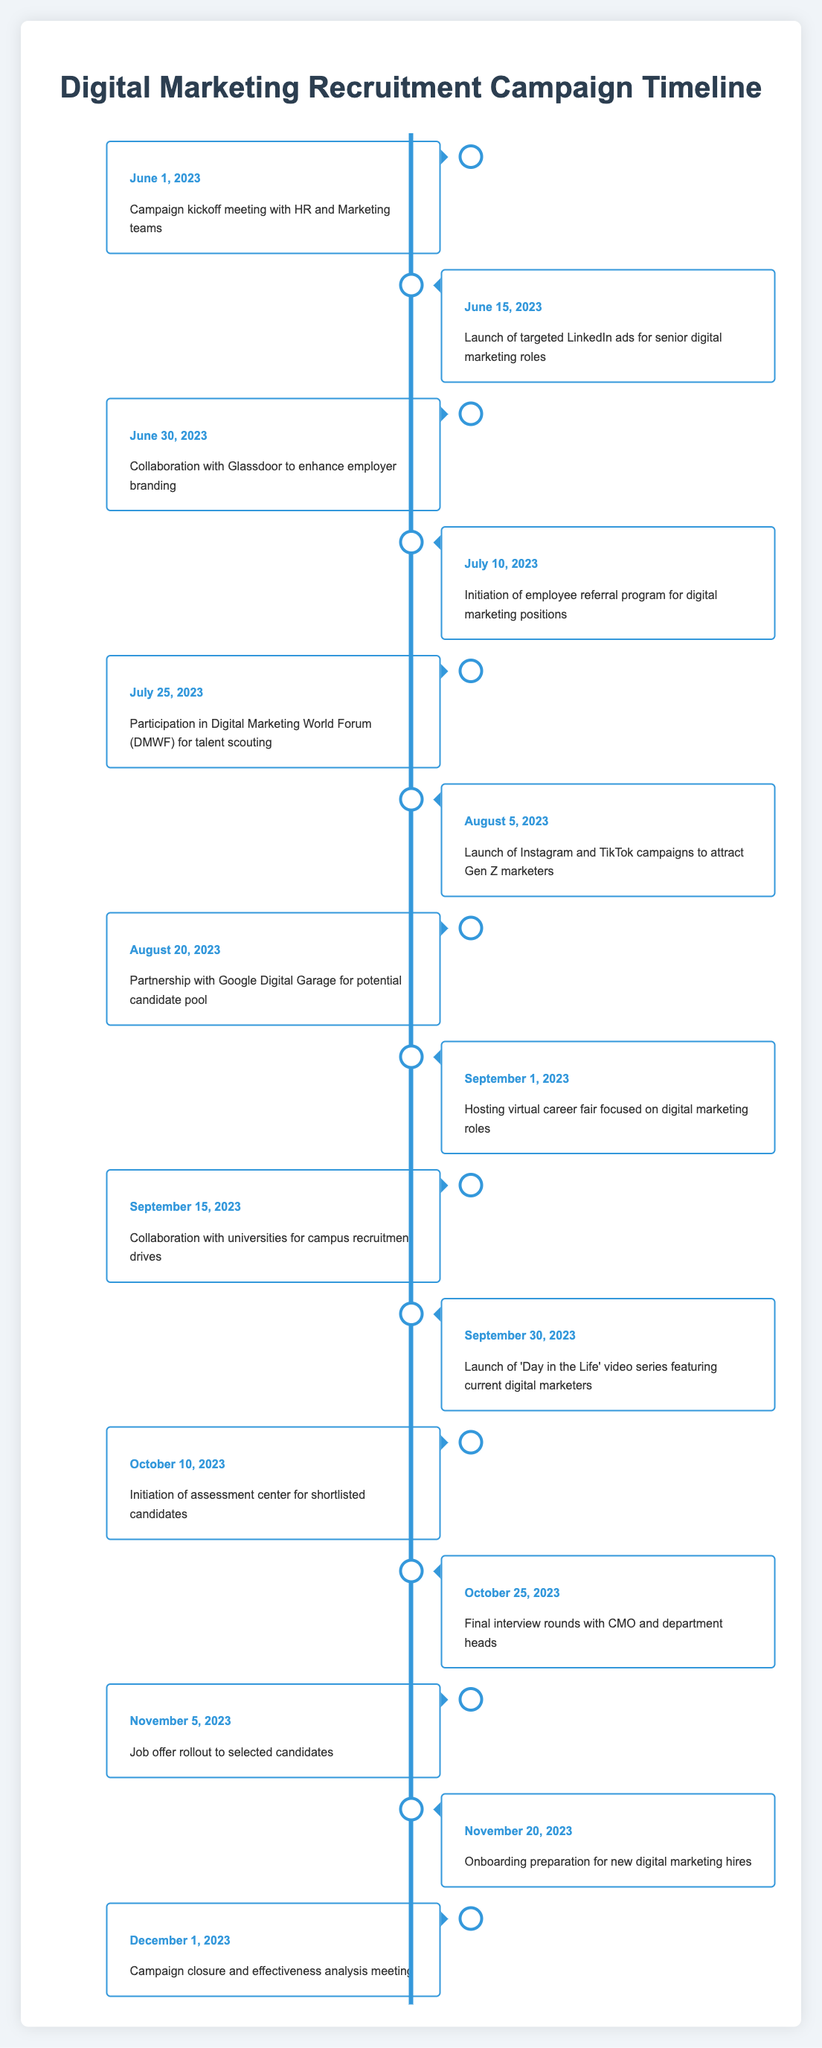What event occurred on June 30, 2023? The table shows that on June 30, 2023, the event was "Collaboration with Glassdoor to enhance employer branding." This can be found directly in the row corresponding to that date.
Answer: Collaboration with Glassdoor to enhance employer branding How many events took place in July 2023? The table lists two events in July: July 10, 2023 (Initiation of employee referral program for digital marketing positions) and July 25, 2023 (Participation in Digital Marketing World Forum for talent scouting). By counting the entries for that month, a total of two events can be confirmed.
Answer: 2 Did the campaign include an Instagram and TikTok campaign? The table states that on August 5, 2023, there was a "Launch of Instagram and TikTok campaigns to attract Gen Z marketers." Thus, it confirms that such campaigns were indeed part of the recruitment strategy.
Answer: Yes What was the last event recorded in the timeline? According to the table, the last event is noted as "Campaign closure and effectiveness analysis meeting" occurring on December 1, 2023. This can be found as the final entry in the timeline.
Answer: Campaign closure and effectiveness analysis meeting How many days were there between the campaign kickoff and the job offer rollout? The campaign kickoff was on June 1, 2023, and the job offer rollout occurred on November 5, 2023. To find the difference, we calculate the total number of days: June has 30 days (29 remaining after June 1), July has 31, August has 31, September has 30, October has 31, and November has 5 days. Adding these gives: 29 + 31 + 31 + 30 + 31 + 5 =  28 + 31 + 31 + 30 + 31 + 5 =  29 + 31 + 31 + 30 + 31 + 5 =  29 + 100 =  31 + 50 =  62 + 20 =  82 It totals to 157 days.
Answer: 157 days 